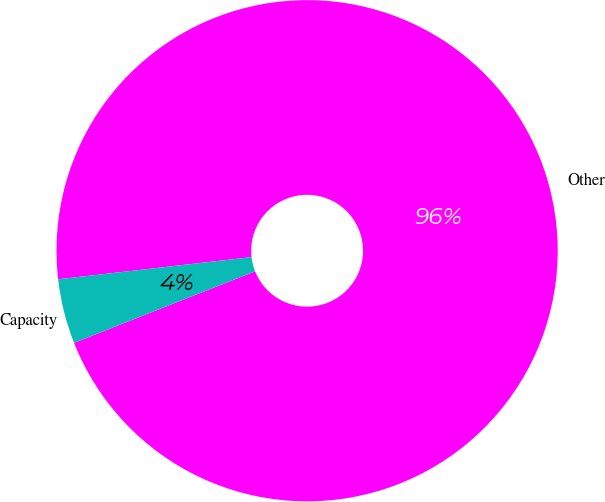Convert chart. <chart><loc_0><loc_0><loc_500><loc_500><pie_chart><fcel>Other<fcel>Capacity<nl><fcel>95.83%<fcel>4.17%<nl></chart> 